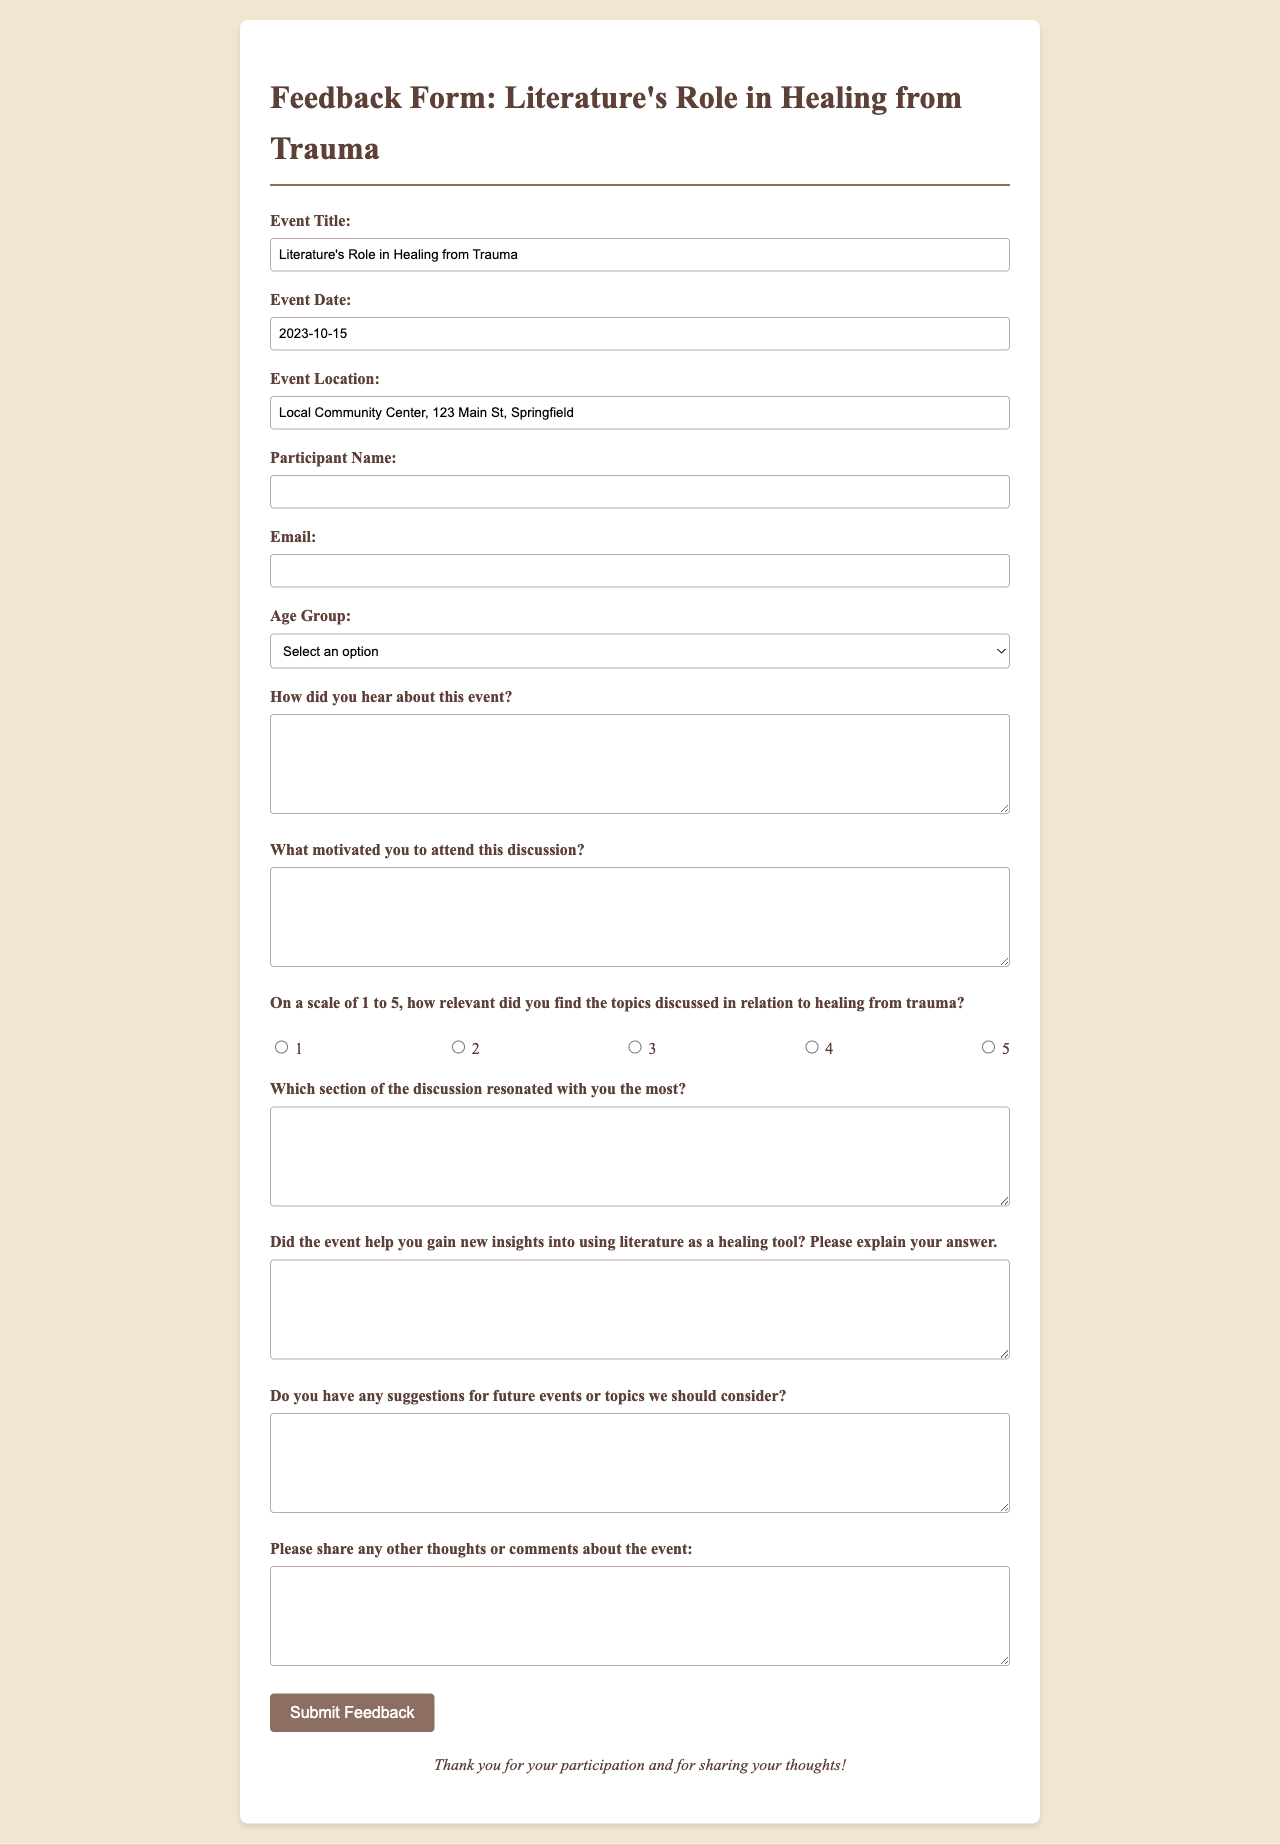What is the event title? The event title is specified in the document as the main topic of discussion.
Answer: Literature's Role in Healing from Trauma What is the event date? The date of the event is provided in the document as part of the event details.
Answer: 2023-10-15 Where is the event located? The location of the event is mentioned as a specific address in the document.
Answer: Local Community Center, 123 Main St, Springfield What age group option includes individuals aged 31 to 50? The age group options are listed in the document, and one specific option refers to this age range.
Answer: 31-50 On a scale of 1 to 5, what is the highest rating for relevance? The scale for rating relevance is specified in the document, where a number indicates the rating level.
Answer: 5 Which section of the discussion is required for feedback? The document requires feedback on a specific section of the discussion that resonated with the participant.
Answer: Which section of the discussion resonated with you the most? What type of feedback is requested regarding insights gained? The document requests participants to explain their thoughts on insights gained from the event.
Answer: Did the event help you gain new insights into using literature as a healing tool? What type of suggestions are participants asked to provide? The document encourages participants to offer suggestions related to future events or topics.
Answer: Do you have any suggestions for future events or topics we should consider? 